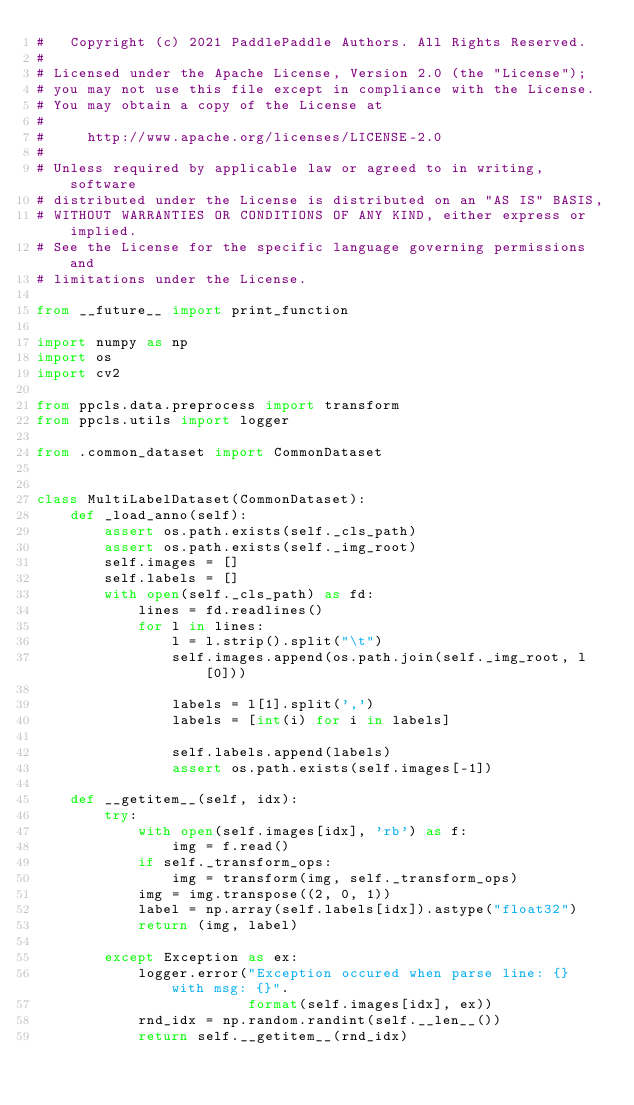Convert code to text. <code><loc_0><loc_0><loc_500><loc_500><_Python_>#   Copyright (c) 2021 PaddlePaddle Authors. All Rights Reserved.
#
# Licensed under the Apache License, Version 2.0 (the "License");
# you may not use this file except in compliance with the License.
# You may obtain a copy of the License at
#
#     http://www.apache.org/licenses/LICENSE-2.0
#
# Unless required by applicable law or agreed to in writing, software
# distributed under the License is distributed on an "AS IS" BASIS,
# WITHOUT WARRANTIES OR CONDITIONS OF ANY KIND, either express or implied.
# See the License for the specific language governing permissions and
# limitations under the License.

from __future__ import print_function

import numpy as np
import os
import cv2

from ppcls.data.preprocess import transform
from ppcls.utils import logger

from .common_dataset import CommonDataset


class MultiLabelDataset(CommonDataset):
    def _load_anno(self):
        assert os.path.exists(self._cls_path)
        assert os.path.exists(self._img_root)
        self.images = []
        self.labels = []
        with open(self._cls_path) as fd:
            lines = fd.readlines()
            for l in lines:
                l = l.strip().split("\t")
                self.images.append(os.path.join(self._img_root, l[0]))

                labels = l[1].split(',')
                labels = [int(i) for i in labels]

                self.labels.append(labels)
                assert os.path.exists(self.images[-1])

    def __getitem__(self, idx):
        try:
            with open(self.images[idx], 'rb') as f:
                img = f.read()
            if self._transform_ops:
                img = transform(img, self._transform_ops)
            img = img.transpose((2, 0, 1))
            label = np.array(self.labels[idx]).astype("float32")
            return (img, label)

        except Exception as ex:
            logger.error("Exception occured when parse line: {} with msg: {}".
                         format(self.images[idx], ex))
            rnd_idx = np.random.randint(self.__len__())
            return self.__getitem__(rnd_idx)
</code> 